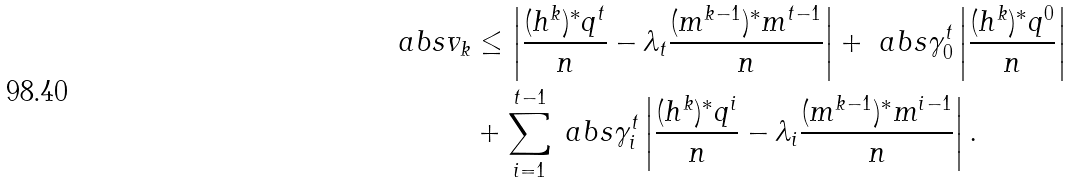<formula> <loc_0><loc_0><loc_500><loc_500>\ a b s { v _ { k } } & \leq \left | \frac { ( h ^ { k } ) ^ { * } q ^ { t } } { n } - \lambda _ { t } \frac { ( m ^ { k - 1 } ) ^ { * } m ^ { t - 1 } } { n } \right | + \ a b s { \gamma _ { 0 } ^ { t } } \left | \frac { ( h ^ { k } ) ^ { * } q ^ { 0 } } { n } \right | \\ & + \sum _ { i = 1 } ^ { t - 1 } \ a b s { \gamma _ { i } ^ { t } } \left | \frac { ( h ^ { k } ) ^ { * } q ^ { i } } { n } - \lambda _ { i } \frac { ( m ^ { k - 1 } ) ^ { * } m ^ { i - 1 } } { n } \right | .</formula> 